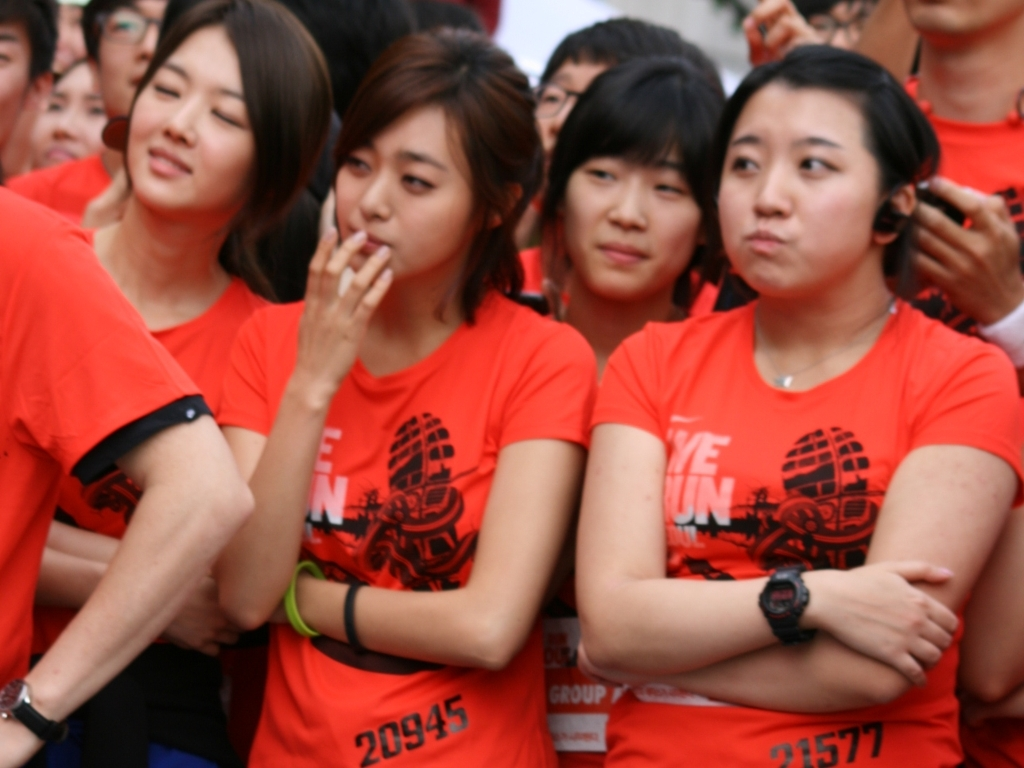What information can we gather about the event taking place? The red T-shirts adorned with numbers and a graphic hint at a communal athletic event, such as a charity run or marathon. The environment looks informal and open-air, suggesting the event is accessible to the public. Given the diversity of the crowd and the participant numbers, it could be a large-scale event drawing together people from different backgrounds to support a cause or simply to foster a sense of community. 